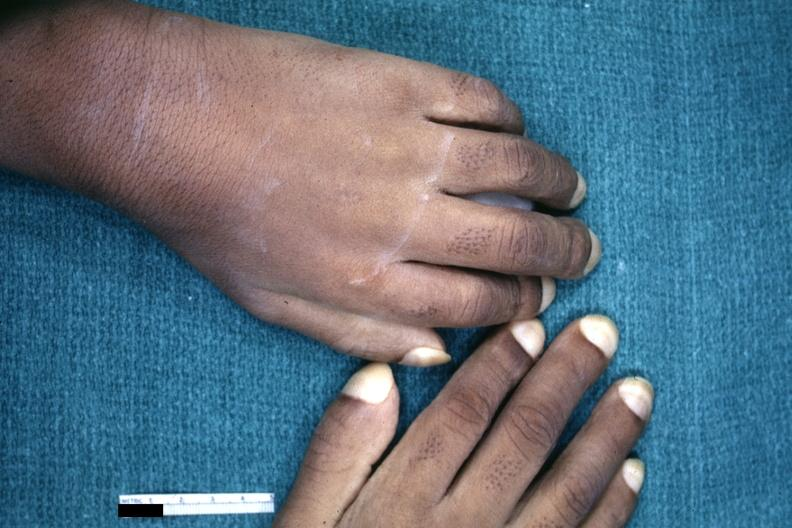s normal immature infant present?
Answer the question using a single word or phrase. No 